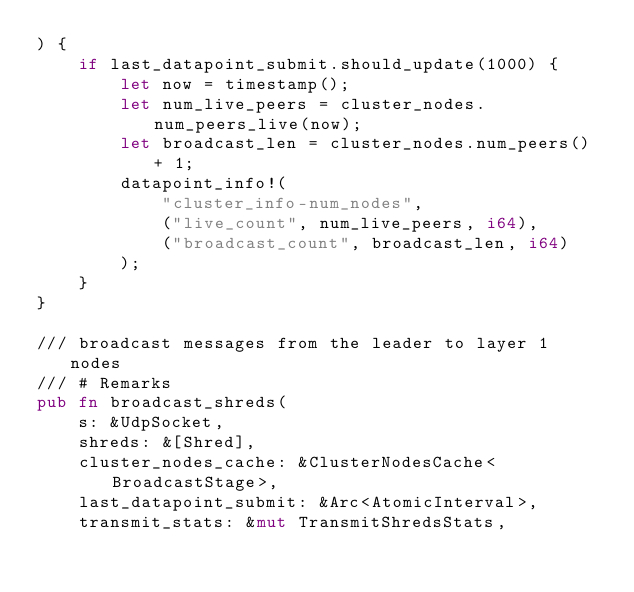<code> <loc_0><loc_0><loc_500><loc_500><_Rust_>) {
    if last_datapoint_submit.should_update(1000) {
        let now = timestamp();
        let num_live_peers = cluster_nodes.num_peers_live(now);
        let broadcast_len = cluster_nodes.num_peers() + 1;
        datapoint_info!(
            "cluster_info-num_nodes",
            ("live_count", num_live_peers, i64),
            ("broadcast_count", broadcast_len, i64)
        );
    }
}

/// broadcast messages from the leader to layer 1 nodes
/// # Remarks
pub fn broadcast_shreds(
    s: &UdpSocket,
    shreds: &[Shred],
    cluster_nodes_cache: &ClusterNodesCache<BroadcastStage>,
    last_datapoint_submit: &Arc<AtomicInterval>,
    transmit_stats: &mut TransmitShredsStats,</code> 